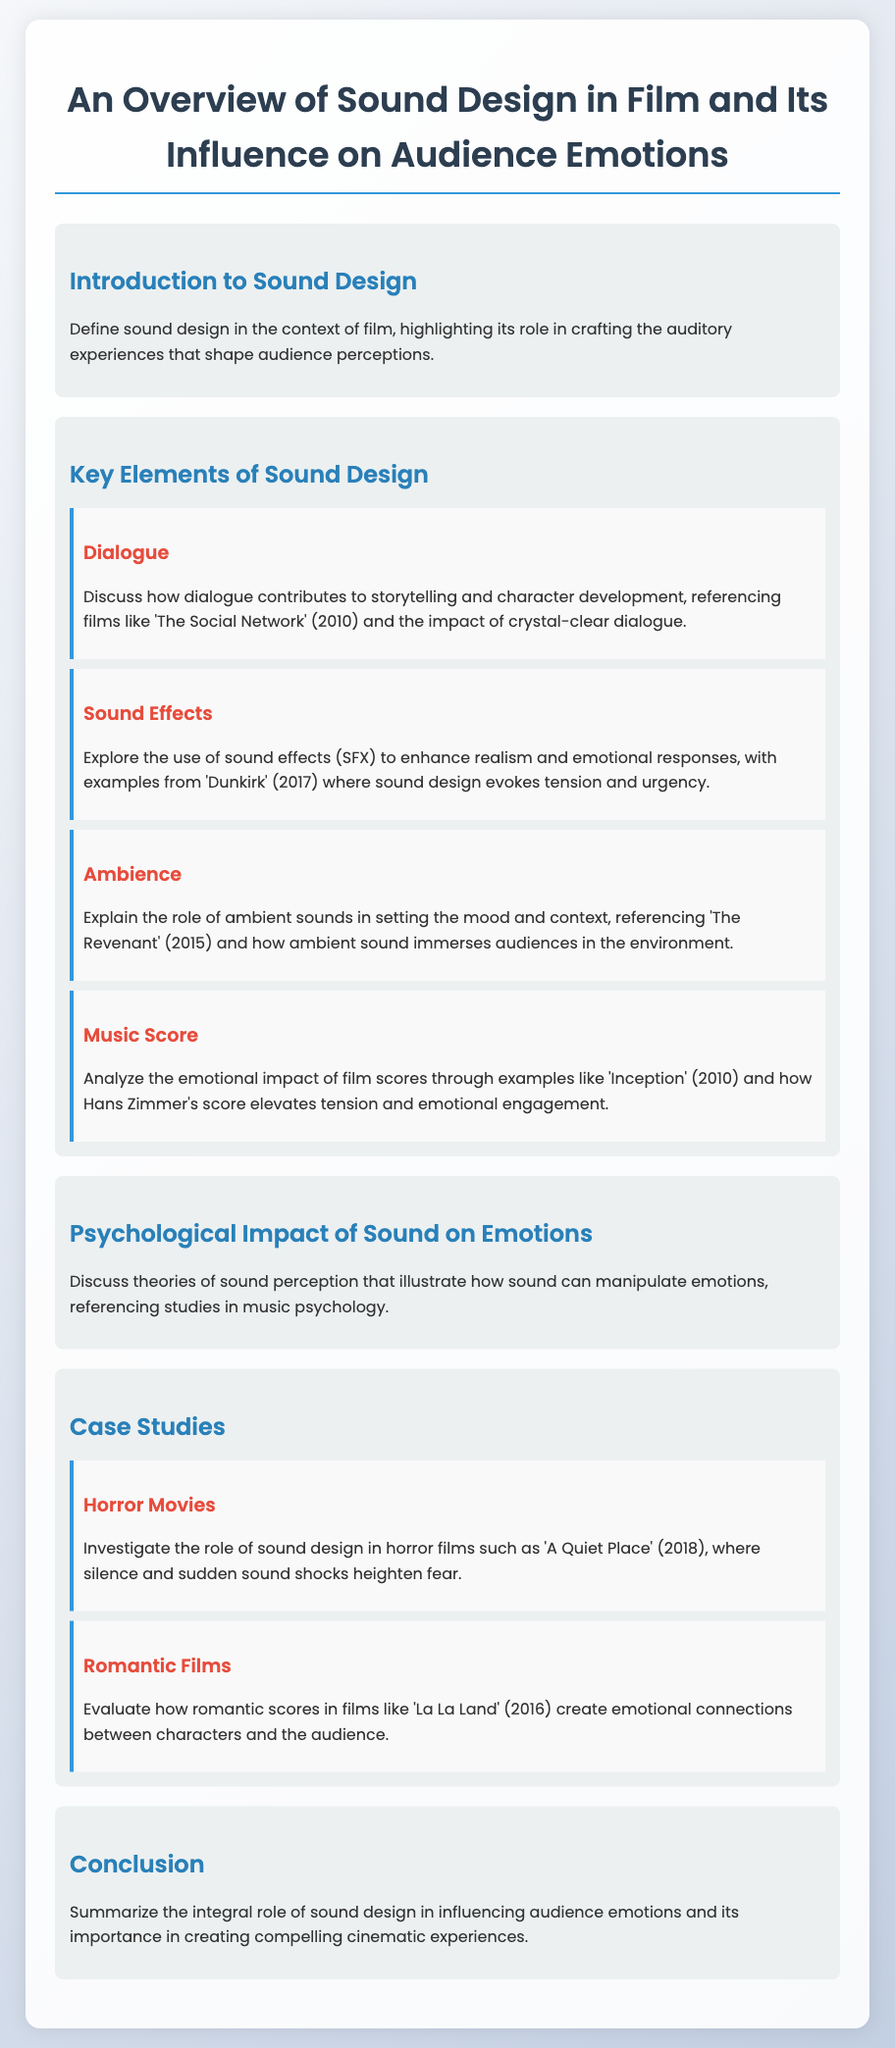What is sound design? Sound design is defined in the context of film, highlighting its role in crafting the auditory experiences that shape audience perceptions.
Answer: Auditory experiences Which film is referenced in the dialogue section? 'The Social Network' (2010) is referenced in the dialogue section as an example of how dialogue contributes to storytelling.
Answer: The Social Network What is one example of sound effects enhancing realism? The example given in the document for sound effects enhancing realism is from 'Dunkirk' (2017).
Answer: Dunkirk Which film's ambient sound immerses audiences in the environment? 'The Revenant' (2015) is referenced for the role of ambient sounds in immersing audiences in the environment.
Answer: The Revenant Who composed the music score for 'Inception'? The document mentions Hans Zimmer as the composer for the music score of 'Inception' (2010).
Answer: Hans Zimmer What genre of film is examined for sound design's role in increasing fear? The document examines horror films, specifically 'A Quiet Place' (2018), to discuss sound design's role in fear.
Answer: Horror films Which film is noted for romantic scores creating emotional connections? 'La La Land' (2016) is evaluated for its romantic scores that create emotional connections between characters and the audience.
Answer: La La Land What psychological aspect does the document discuss regarding sound? The document discusses theories of sound perception that illustrate how sound can manipulate emotions.
Answer: Sound perception What is the conclusion about sound design's role? The conclusion summarizes the integral role of sound design in influencing audience emotions and its importance.
Answer: Integral role 